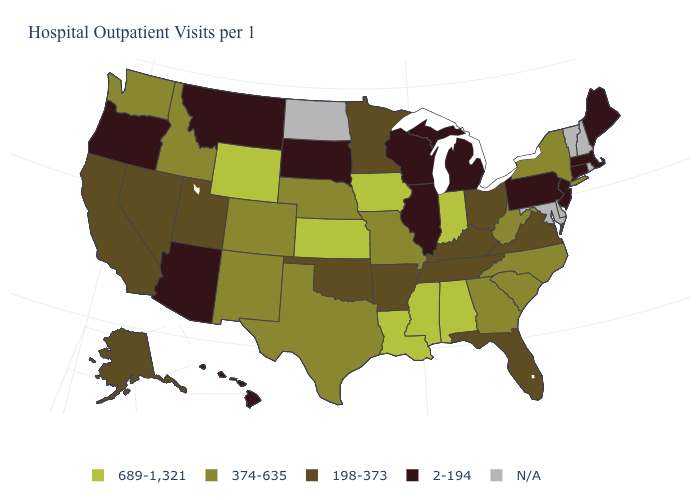Name the states that have a value in the range 198-373?
Concise answer only. Alaska, Arkansas, California, Florida, Kentucky, Minnesota, Nevada, Ohio, Oklahoma, Tennessee, Utah, Virginia. How many symbols are there in the legend?
Answer briefly. 5. How many symbols are there in the legend?
Give a very brief answer. 5. What is the value of Indiana?
Short answer required. 689-1,321. What is the value of Arizona?
Short answer required. 2-194. Name the states that have a value in the range 689-1,321?
Write a very short answer. Alabama, Indiana, Iowa, Kansas, Louisiana, Mississippi, Wyoming. Name the states that have a value in the range 689-1,321?
Short answer required. Alabama, Indiana, Iowa, Kansas, Louisiana, Mississippi, Wyoming. What is the lowest value in states that border Kentucky?
Give a very brief answer. 2-194. Is the legend a continuous bar?
Quick response, please. No. What is the value of Maryland?
Write a very short answer. N/A. Which states have the lowest value in the USA?
Concise answer only. Arizona, Connecticut, Hawaii, Illinois, Maine, Massachusetts, Michigan, Montana, New Jersey, Oregon, Pennsylvania, South Dakota, Wisconsin. Among the states that border Wisconsin , which have the highest value?
Short answer required. Iowa. What is the lowest value in the USA?
Be succinct. 2-194. What is the value of Mississippi?
Quick response, please. 689-1,321. How many symbols are there in the legend?
Write a very short answer. 5. 